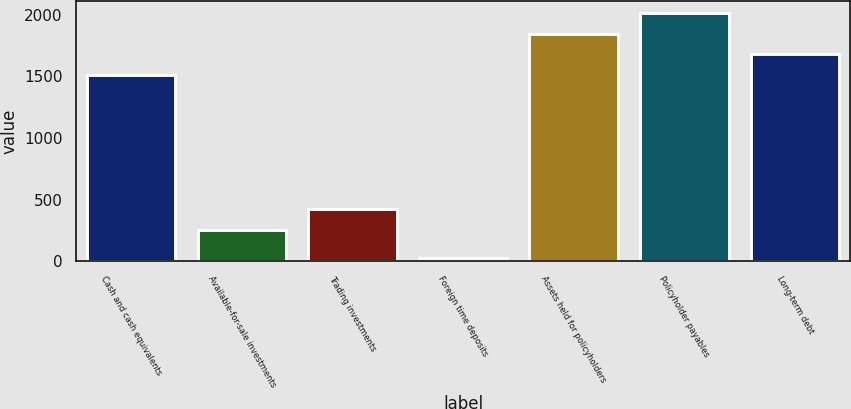Convert chart to OTSL. <chart><loc_0><loc_0><loc_500><loc_500><bar_chart><fcel>Cash and cash equivalents<fcel>Available-for-sale investments<fcel>Trading investments<fcel>Foreign time deposits<fcel>Assets held for policyholders<fcel>Policyholder payables<fcel>Long-term debt<nl><fcel>1514.2<fcel>255.9<fcel>422.73<fcel>29.6<fcel>1847.86<fcel>2014.69<fcel>1681.03<nl></chart> 